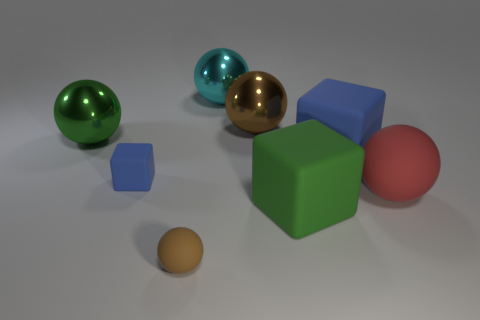How many blue blocks must be subtracted to get 1 blue blocks? 1 Subtract all green spheres. How many spheres are left? 4 Subtract all big cyan metal balls. How many balls are left? 4 Subtract all yellow spheres. Subtract all blue blocks. How many spheres are left? 5 Add 1 small matte objects. How many objects exist? 9 Subtract all spheres. How many objects are left? 3 Add 6 large balls. How many large balls are left? 10 Add 4 small rubber balls. How many small rubber balls exist? 5 Subtract 0 green cylinders. How many objects are left? 8 Subtract all large blue matte cylinders. Subtract all green spheres. How many objects are left? 7 